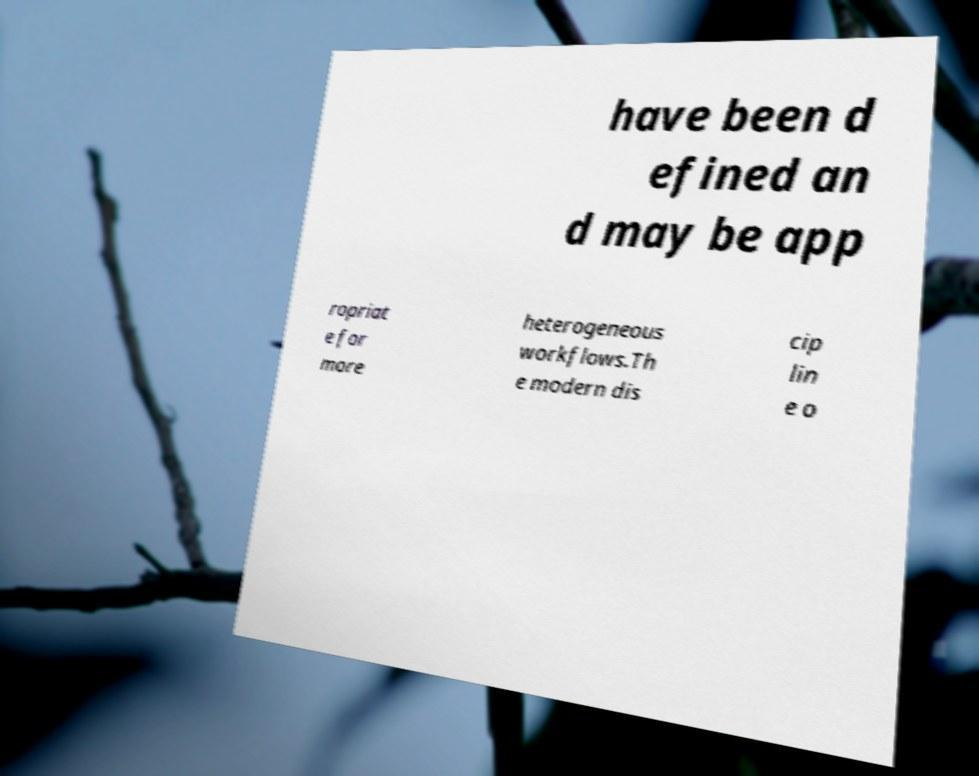Could you assist in decoding the text presented in this image and type it out clearly? have been d efined an d may be app ropriat e for more heterogeneous workflows.Th e modern dis cip lin e o 